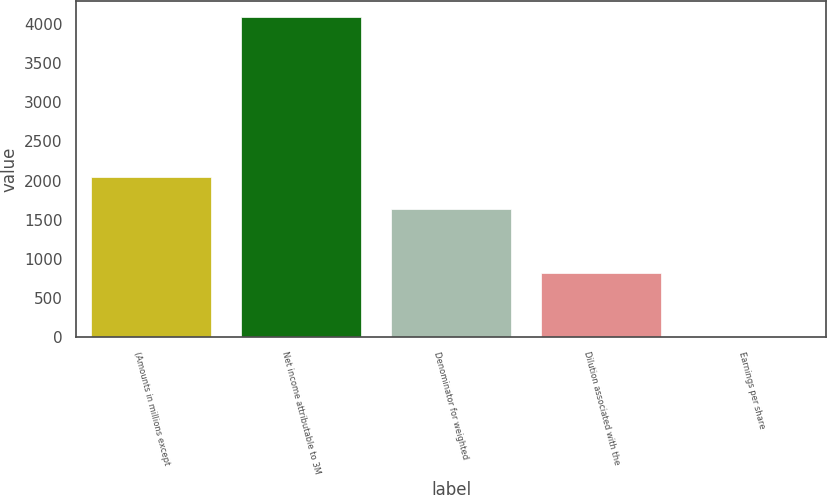Convert chart to OTSL. <chart><loc_0><loc_0><loc_500><loc_500><bar_chart><fcel>(Amounts in millions except<fcel>Net income attributable to 3M<fcel>Denominator for weighted<fcel>Dilution associated with the<fcel>Earnings per share<nl><fcel>2045.33<fcel>4085<fcel>1637.39<fcel>821.51<fcel>5.63<nl></chart> 